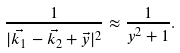<formula> <loc_0><loc_0><loc_500><loc_500>\frac { 1 } { | \vec { k _ { 1 } } - \vec { k _ { 2 } } + \vec { y } | ^ { 2 } } \approx \frac { 1 } { y ^ { 2 } + 1 } .</formula> 